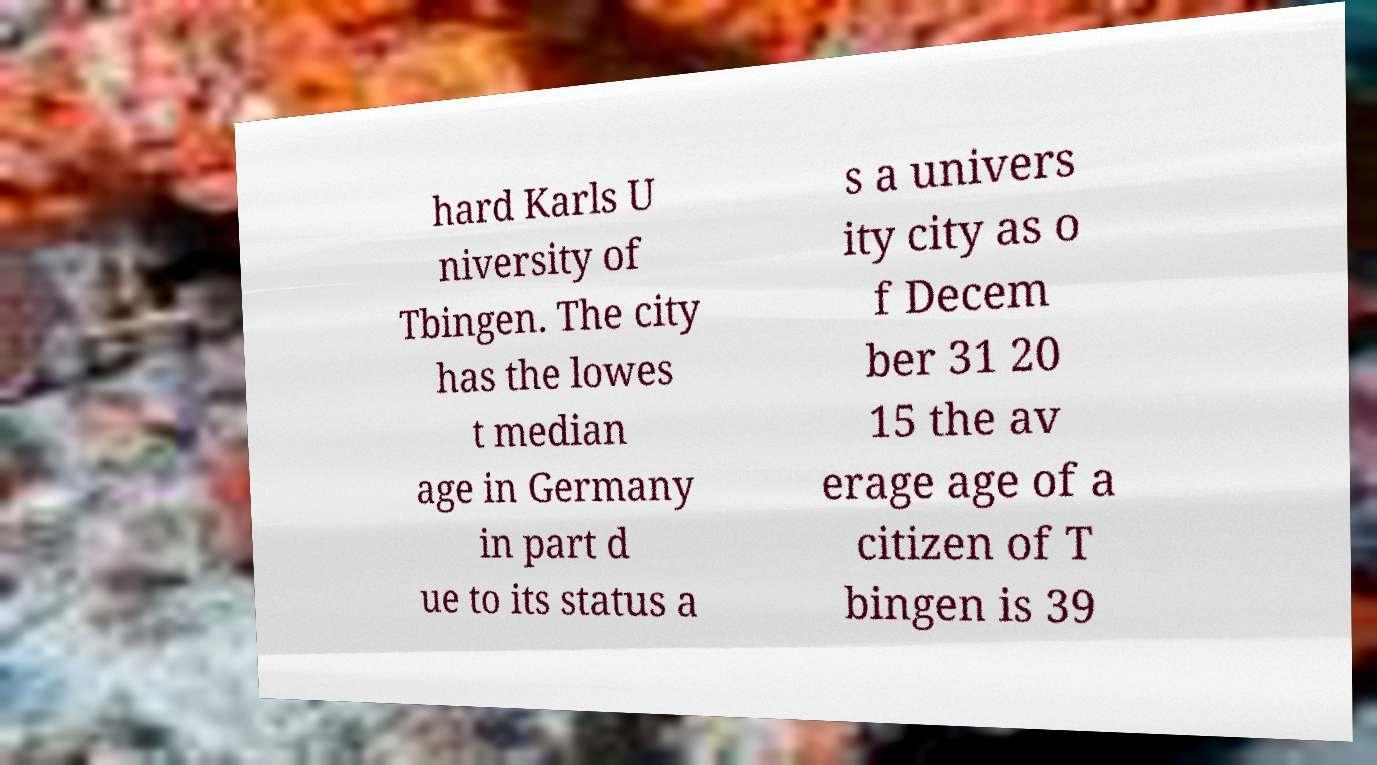What messages or text are displayed in this image? I need them in a readable, typed format. hard Karls U niversity of Tbingen. The city has the lowes t median age in Germany in part d ue to its status a s a univers ity city as o f Decem ber 31 20 15 the av erage age of a citizen of T bingen is 39 